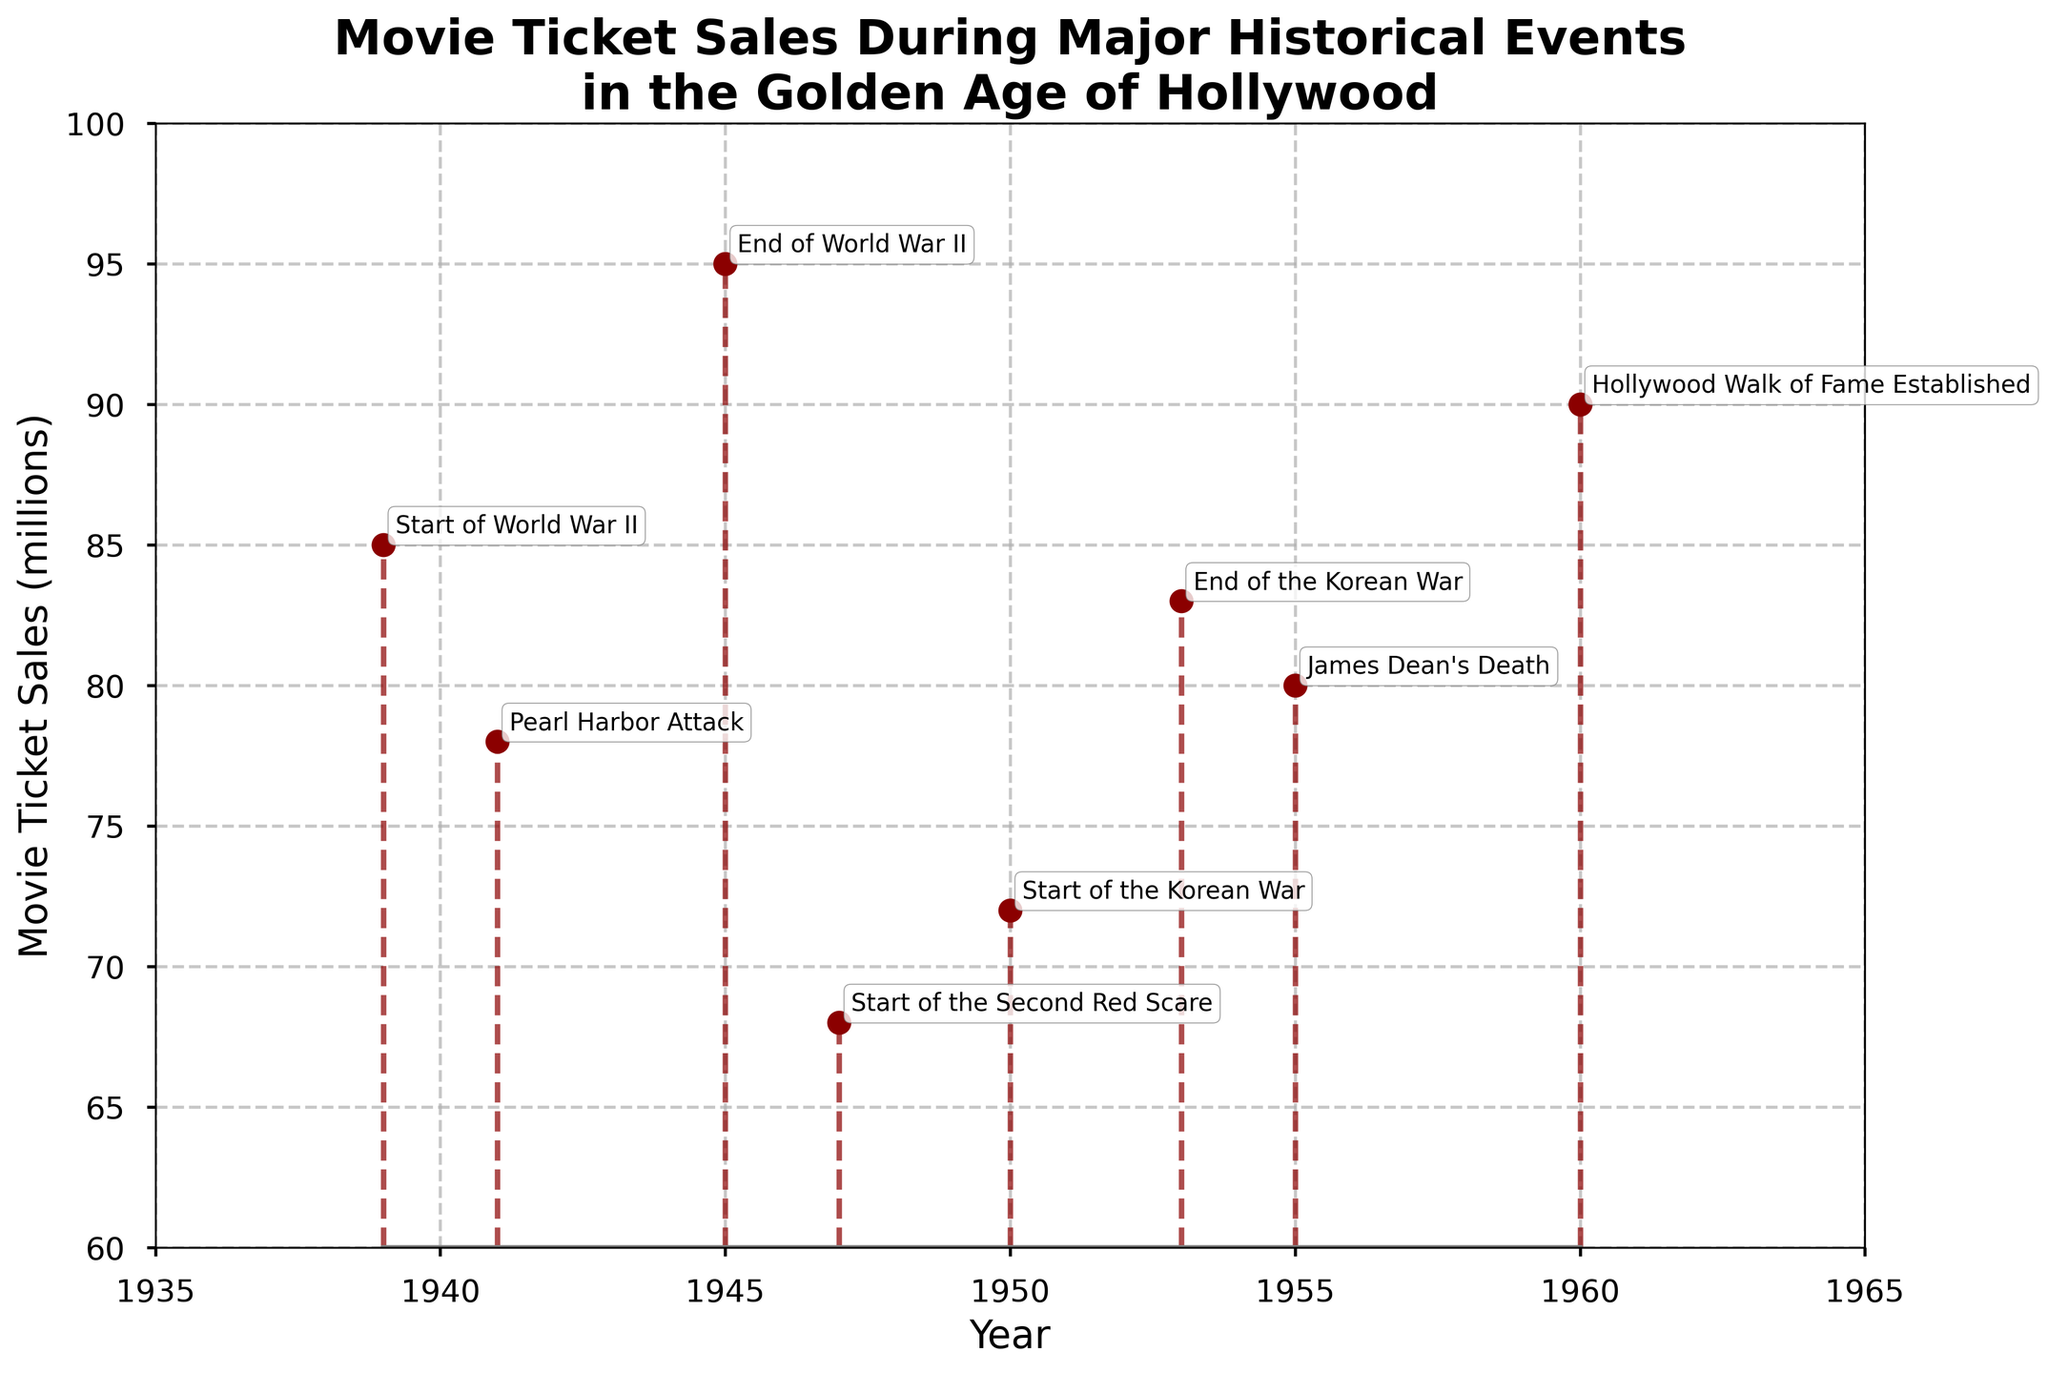What is the title of the figure? The title of the figure is displayed at the top, and it reads "Movie Ticket Sales During Major Historical Events in the Golden Age of Hollywood".
Answer: Movie Ticket Sales During Major Historical Events in the Golden Age of Hollywood How many data points are plotted in the figure? The figure plots one data point for each historical event listed in the data. Counting these points gives us eight.
Answer: 8 Which event had the highest movie ticket sales, and what were the sales figures? The highest point on the vertical axis corresponds to the event at the top of the y-axis. The "End of World War II" in 1945 had the highest sales with 95 million.
Answer: End of World War II, 95 million During which event did movie ticket sales drop below 70 million? By examining the figure, the stem plot shows that sales dropped below 70 million during the "Start of the Second Red Scare" in 1947.
Answer: Start of the Second Red Scare What is the range of years displayed on the x-axis? The x-axis labels display the years, starting from 1935 and ending at 1965.
Answer: 1935 to 1965 Which two historical events had the closest movie ticket sales figures, and what were those figures? Looking at points that are closest vertically, the "Pearl Harbor Attack" in 1941 and the "Start of the Second Red Scare" in 1947 had close values of 78 and 68 million, respectively.
Answer: Pearl Harbor Attack and Start of the Second Red Scare, 78 million and 68 million Compare the movie ticket sales during the start and end of World War II. What difference do you observe? The "Start of World War II" in 1939 had 85 million sales, while the "End of World War II" in 1945 had significantly higher sales at 95 million, a difference of 10 million.
Answer: Sales increased by 10 million Calculate the average movie ticket sales for the events listed. Add all the sales figures: 85 + 78 + 95 + 68 + 72 + 83 + 80 + 90 = 651. Divide by the number of events: 651 / 8 = 81.375.
Answer: 81.375 million Which historical event marked the end of the second highest ticket sales, and what was the ticket sales figure? The second highest point in the figure corresponds to the "Hollywood Walk of Fame Established" in 1960, with ticket sales of 90 million.
Answer: Hollywood Walk of Fame Established, 90 million 